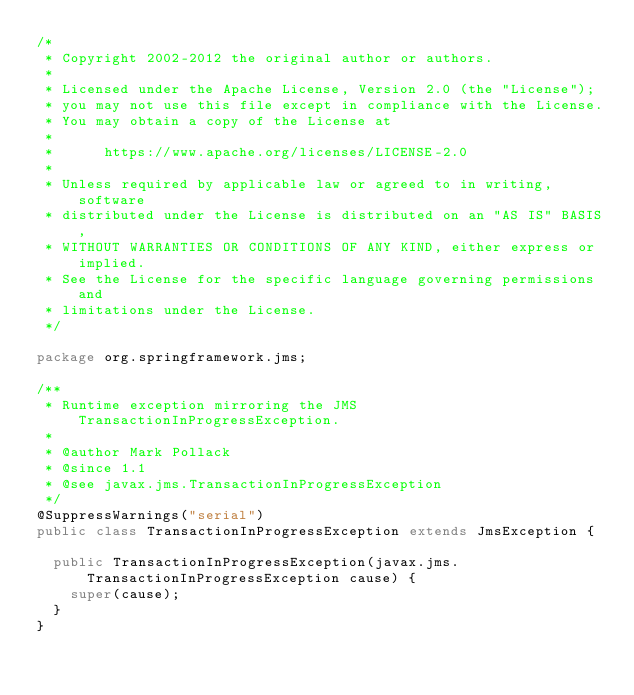Convert code to text. <code><loc_0><loc_0><loc_500><loc_500><_Java_>/*
 * Copyright 2002-2012 the original author or authors.
 *
 * Licensed under the Apache License, Version 2.0 (the "License");
 * you may not use this file except in compliance with the License.
 * You may obtain a copy of the License at
 *
 *      https://www.apache.org/licenses/LICENSE-2.0
 *
 * Unless required by applicable law or agreed to in writing, software
 * distributed under the License is distributed on an "AS IS" BASIS,
 * WITHOUT WARRANTIES OR CONDITIONS OF ANY KIND, either express or implied.
 * See the License for the specific language governing permissions and
 * limitations under the License.
 */

package org.springframework.jms;

/**
 * Runtime exception mirroring the JMS TransactionInProgressException.
 *
 * @author Mark Pollack
 * @since 1.1
 * @see javax.jms.TransactionInProgressException
 */
@SuppressWarnings("serial")
public class TransactionInProgressException extends JmsException {

  public TransactionInProgressException(javax.jms.TransactionInProgressException cause) {
    super(cause);
  }
}
</code> 